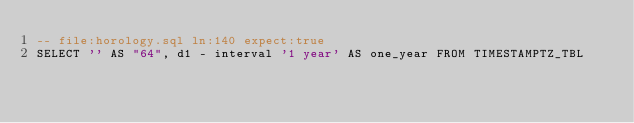Convert code to text. <code><loc_0><loc_0><loc_500><loc_500><_SQL_>-- file:horology.sql ln:140 expect:true
SELECT '' AS "64", d1 - interval '1 year' AS one_year FROM TIMESTAMPTZ_TBL
</code> 